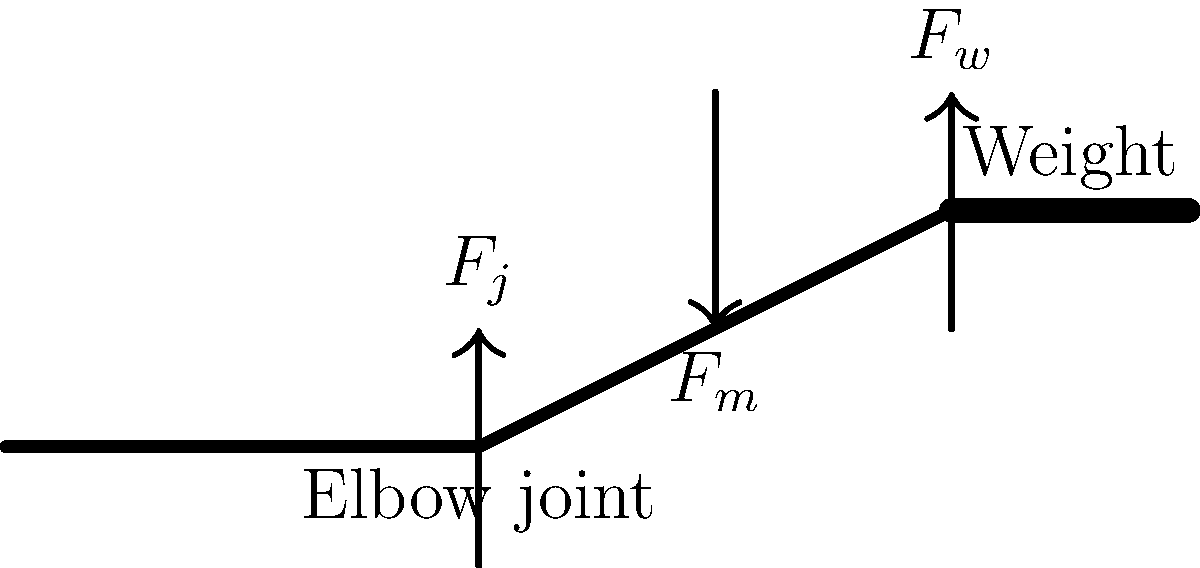As a DIY enthusiast who enjoys weightlifting, you're analyzing the forces acting on your elbow joint during a bicep curl exercise. The diagram shows a simplified representation of your arm holding a weight. If the weight ($F_w$) is 20 N and the muscle force ($F_m$) is 100 N, what is the magnitude of the joint reaction force ($F_j$) at the elbow to maintain equilibrium? To solve this problem, we'll use the principle of equilibrium in biomechanics. The steps are as follows:

1. Identify the forces acting on the system:
   - $F_w$: Weight force (given as 20 N)
   - $F_m$: Muscle force (given as 100 N)
   - $F_j$: Joint reaction force (unknown, to be calculated)

2. Apply the equilibrium condition:
   The sum of all forces must equal zero for the system to be in equilibrium.
   $$\sum F = 0$$

3. Break down the forces into vertical components:
   - $F_w$ is already vertical and pointing downward (negative)
   - $F_m$ is pointing upward (positive)
   - $F_j$ is pointing upward (positive)

4. Set up the equilibrium equation:
   $$F_j + F_m - F_w = 0$$

5. Substitute the known values:
   $$F_j + 100 - 20 = 0$$

6. Solve for $F_j$:
   $$F_j = 20 - 100 = -80 \text{ N}$$

7. Interpret the result:
   The negative sign indicates that the joint reaction force is actually pointing downward, opposite to what was initially assumed in the diagram. This makes sense biomechanically, as the elbow joint must counteract the upward pull of the muscle.

8. Calculate the magnitude of $F_j$:
   $$|F_j| = |-80| = 80 \text{ N}$$

Therefore, the magnitude of the joint reaction force at the elbow is 80 N.
Answer: 80 N 